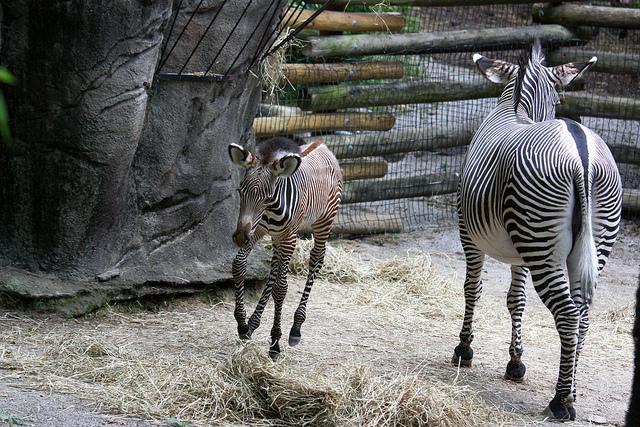How many zebras?
Quick response, please. 2. Are the zebras in a stable?
Answer briefly. Yes. Is the little zebra running or walking?
Quick response, please. Running. Is the zebra about to run through the wall?
Concise answer only. No. 